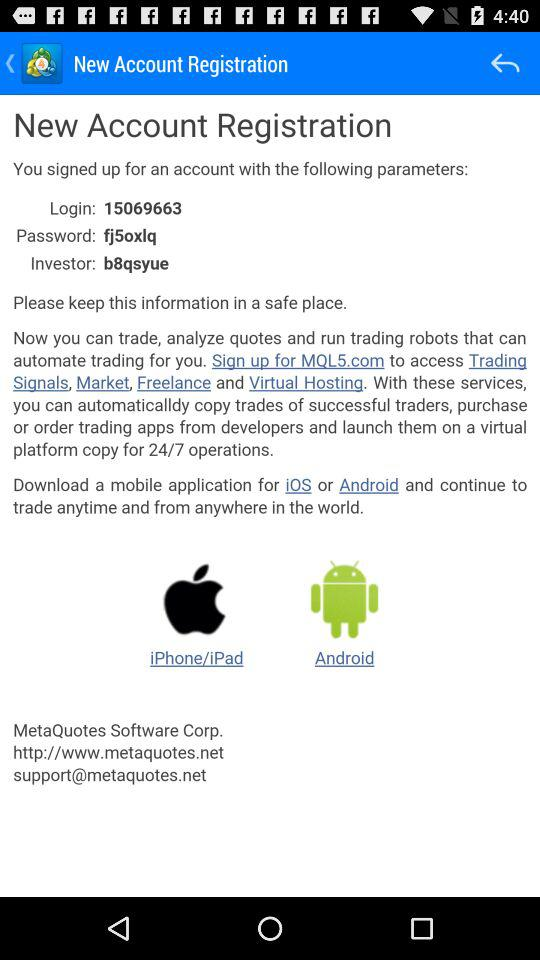What is the support website given on the screen? The support website given on the screen is support@metaquotes.net. 